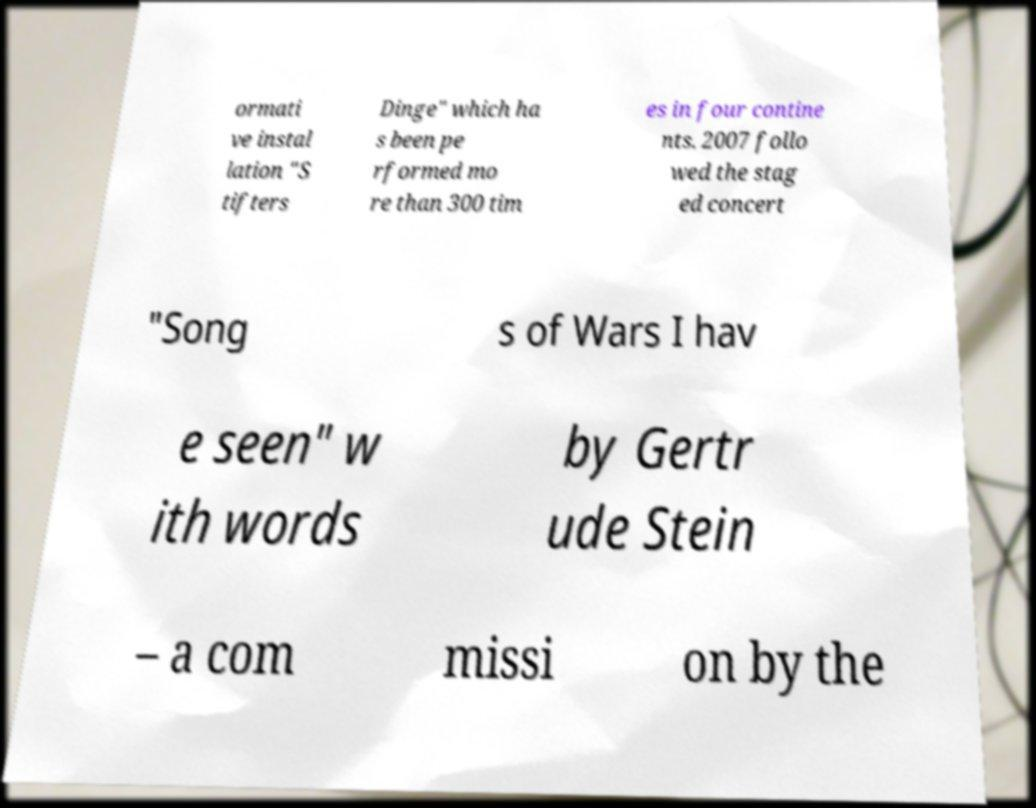Could you extract and type out the text from this image? ormati ve instal lation "S tifters Dinge" which ha s been pe rformed mo re than 300 tim es in four contine nts. 2007 follo wed the stag ed concert "Song s of Wars I hav e seen" w ith words by Gertr ude Stein – a com missi on by the 